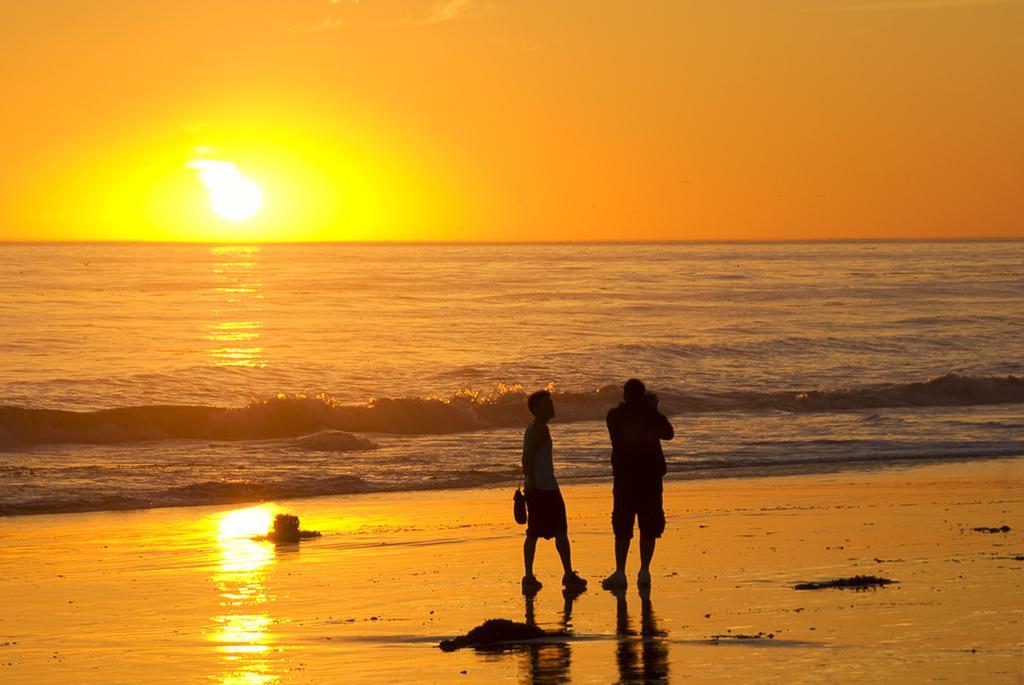In one or two sentences, can you explain what this image depicts? In this image I can see two people standing in-front of the water. These people are wearing the dresses and the bag. In the back I can see the sun and the sky. 